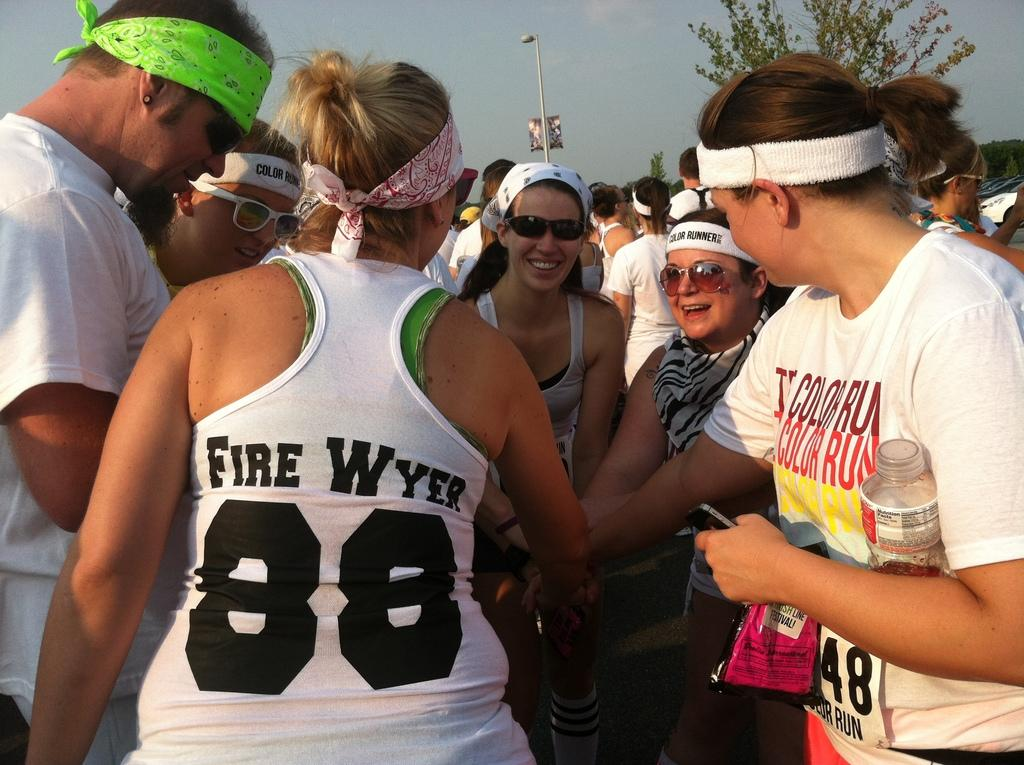<image>
Render a clear and concise summary of the photo. Women athletes wearing a tank top with Fire Wyer on the back. 